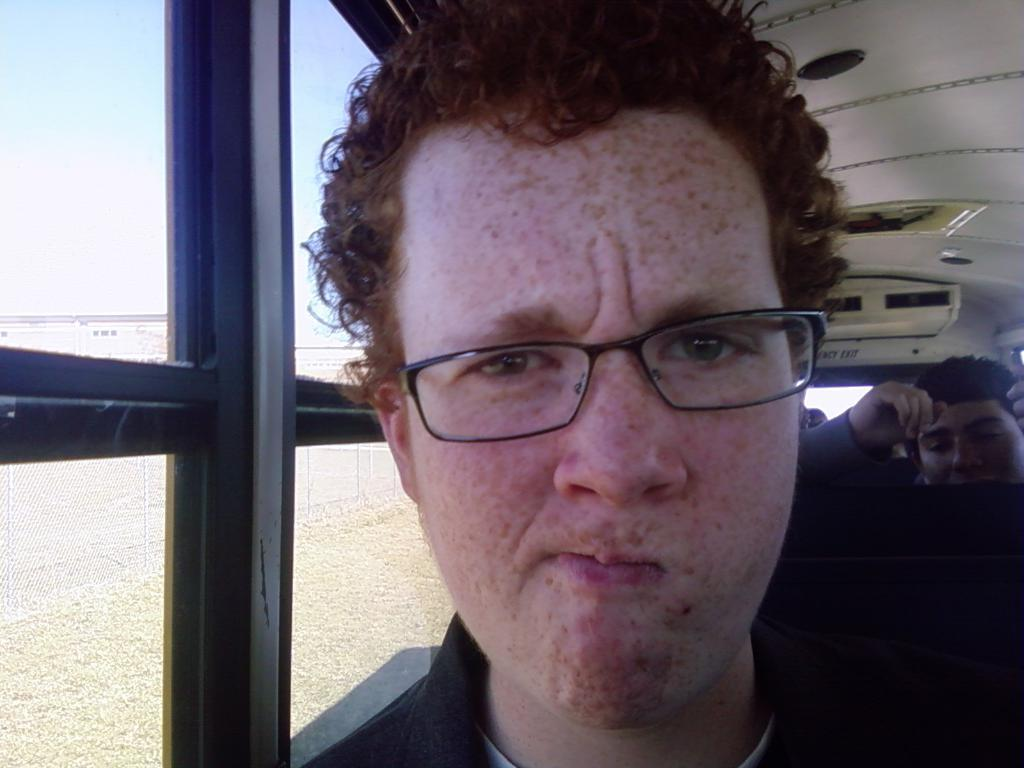What is the man in the image doing? The man is sitting in the image. What accessory is the man wearing? The man is wearing glasses (specs) in the image. What type of material can be seen in the windows in the image? The windows in the image are made of glass. How many friends are visible in the image? There is no mention of friends in the image, so it cannot be determined how many are visible. What type of vessel is being used by the man in the image? There is no vessel present in the image, so it cannot be determined what type is being used. 